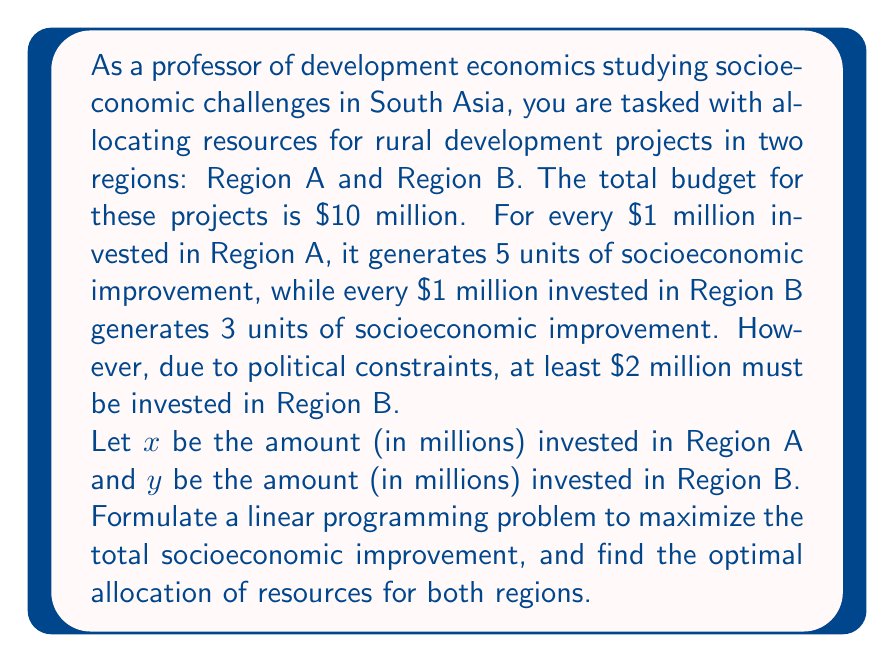Give your solution to this math problem. To solve this problem, we need to formulate a linear programming problem and then solve it. Let's break it down step by step:

1. Define the objective function:
   We want to maximize the total socioeconomic improvement. 
   $$Z = 5x + 3y$$ (where $Z$ is the total socioeconomic improvement)

2. Define the constraints:
   a. Total budget constraint: $x + y = 10$
   b. Minimum investment in Region B: $y \geq 2$
   c. Non-negativity constraints: $x \geq 0$, $y \geq 0$

3. The complete linear programming problem:
   Maximize $Z = 5x + 3y$
   Subject to:
   $$x + y = 10$$
   $$y \geq 2$$
   $$x \geq 0, y \geq 0$$

4. Solving the problem:
   We can solve this graphically or algebraically. Let's use the algebraic method.

   From the budget constraint: $x = 10 - y$

   Substituting this into the objective function:
   $$Z = 5(10 - y) + 3y = 50 - 5y + 3y = 50 - 2y$$

   This shows that $Z$ decreases as $y$ increases. Therefore, to maximize $Z$, we should minimize $y$ while satisfying all constraints.

   The minimum value of $y$ that satisfies all constraints is 2.

   So, the optimal solution is:
   $y = 2$
   $x = 10 - y = 10 - 2 = 8$

5. Checking the solution:
   This solution satisfies all constraints:
   - Budget constraint: $8 + 2 = 10$
   - Minimum investment in Region B: $2 \geq 2$
   - Non-negativity: Both $x$ and $y$ are positive

6. Calculating the maximum socioeconomic improvement:
   $$Z = 5x + 3y = 5(8) + 3(2) = 40 + 6 = 46$$
Answer: The optimal allocation of resources is:
Region A: $8 million
Region B: $2 million
This allocation will generate a maximum of 46 units of socioeconomic improvement. 